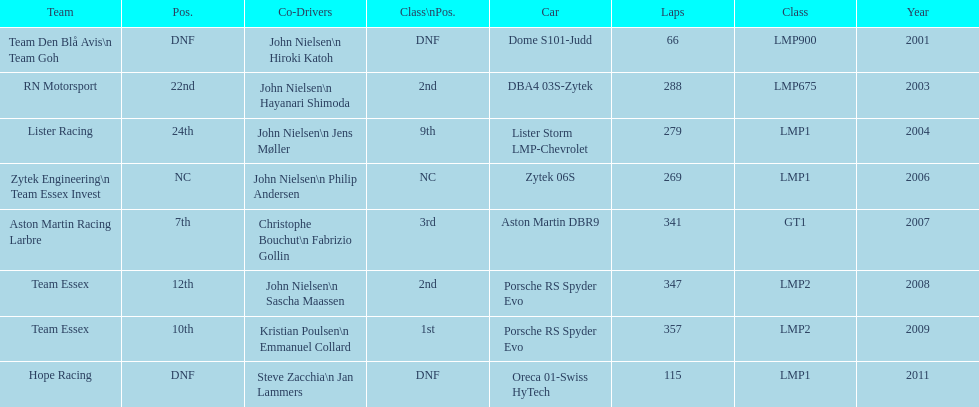How many times was the porsche rs spyder used in competition? 2. 